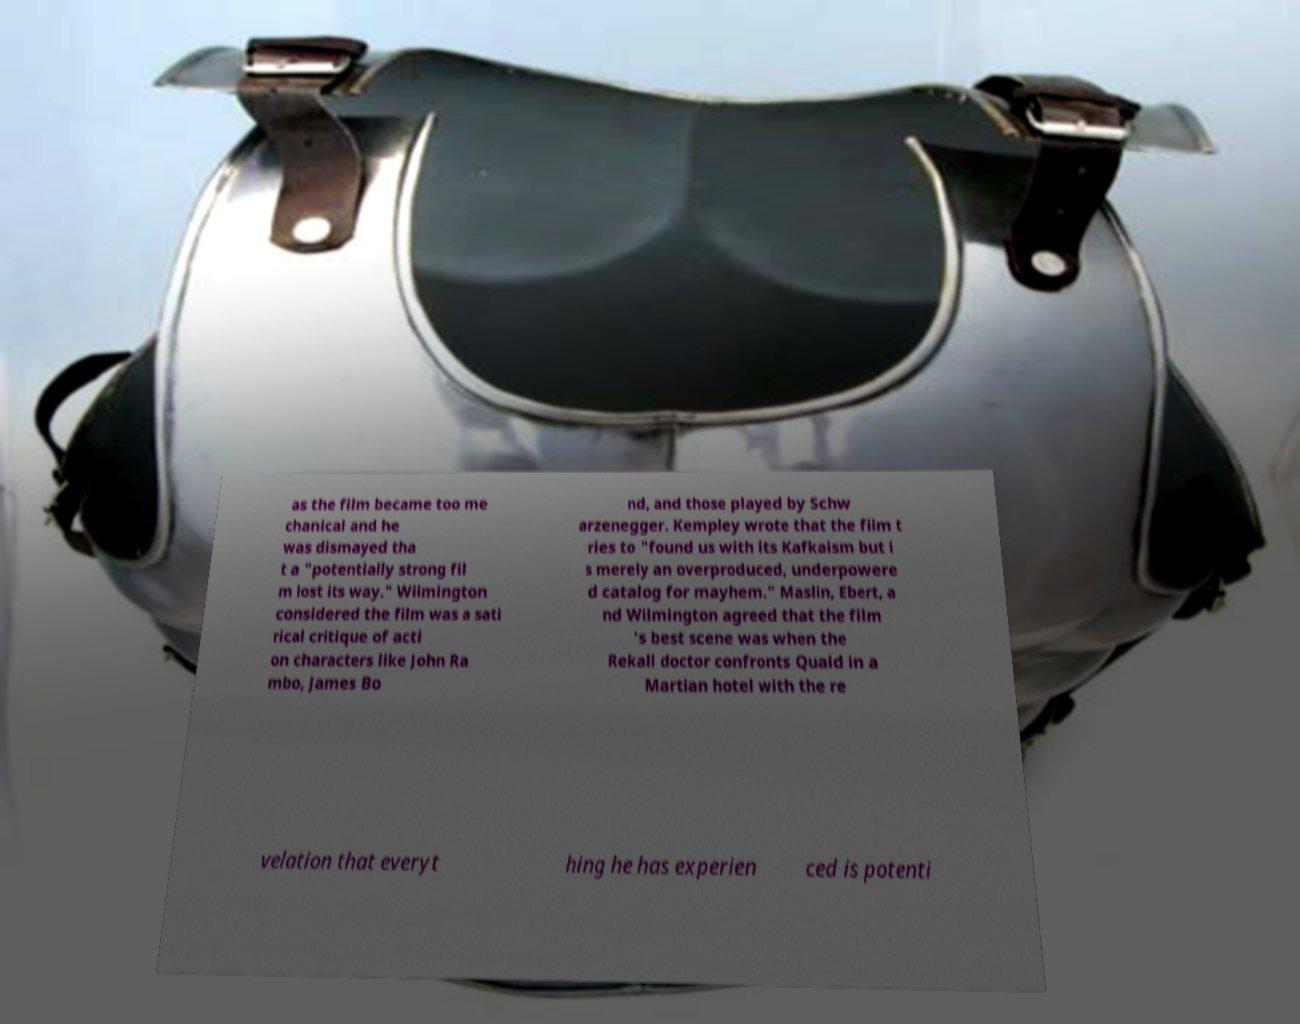Please identify and transcribe the text found in this image. as the film became too me chanical and he was dismayed tha t a "potentially strong fil m lost its way." Wilmington considered the film was a sati rical critique of acti on characters like John Ra mbo, James Bo nd, and those played by Schw arzenegger. Kempley wrote that the film t ries to "found us with its Kafkaism but i s merely an overproduced, underpowere d catalog for mayhem." Maslin, Ebert, a nd Wilmington agreed that the film 's best scene was when the Rekall doctor confronts Quaid in a Martian hotel with the re velation that everyt hing he has experien ced is potenti 